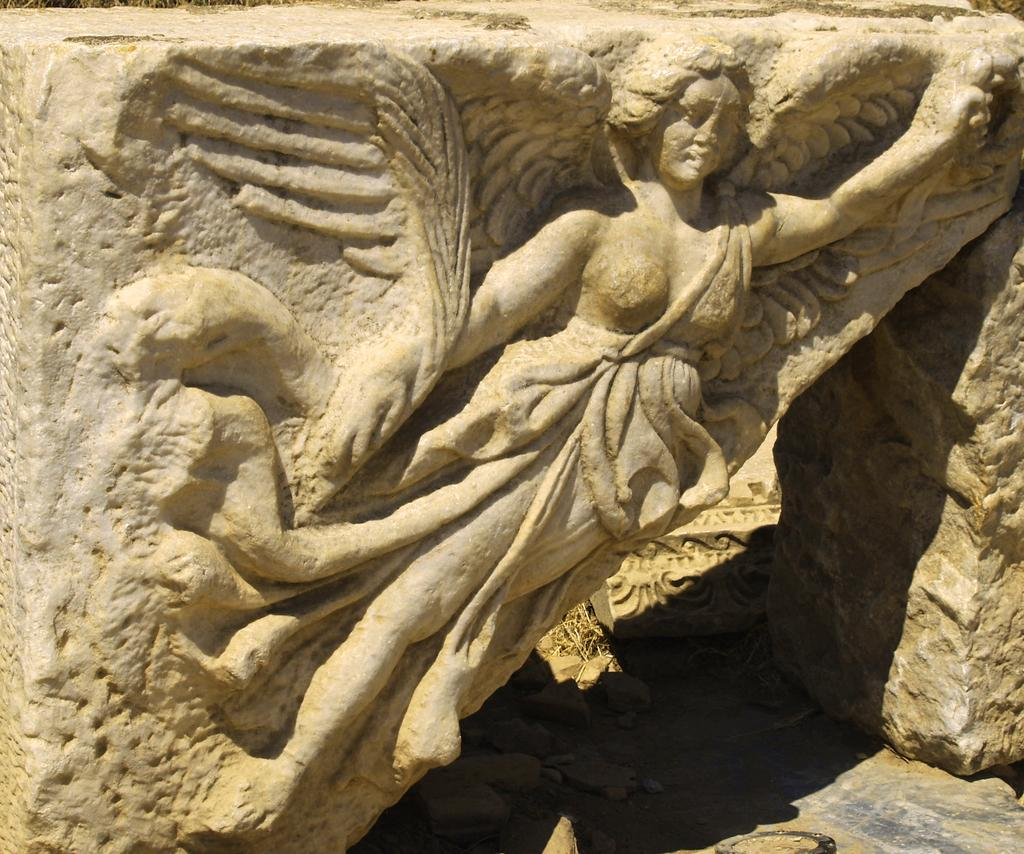What is on the wall in the image? There is a sculpture on the wall in the image. What is located under the sculpture? There are stones under the sculpture in the image. How many oranges are placed on the sculpture in the image? There are no oranges present in the image; the sculpture is on the wall with stones underneath. 